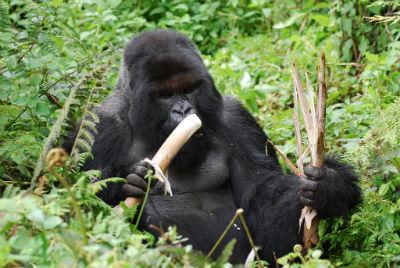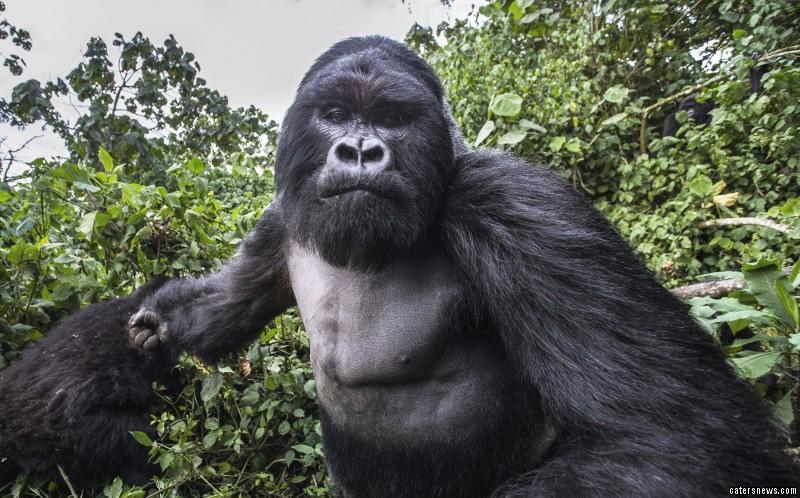The first image is the image on the left, the second image is the image on the right. Analyze the images presented: Is the assertion "In each image there is a single gorilla and it is eating." valid? Answer yes or no. No. The first image is the image on the left, the second image is the image on the right. Evaluate the accuracy of this statement regarding the images: "One image shows a gorilla holding some type of stalk by its face, and the other image features an adult gorilla moving toward the camera.". Is it true? Answer yes or no. Yes. 